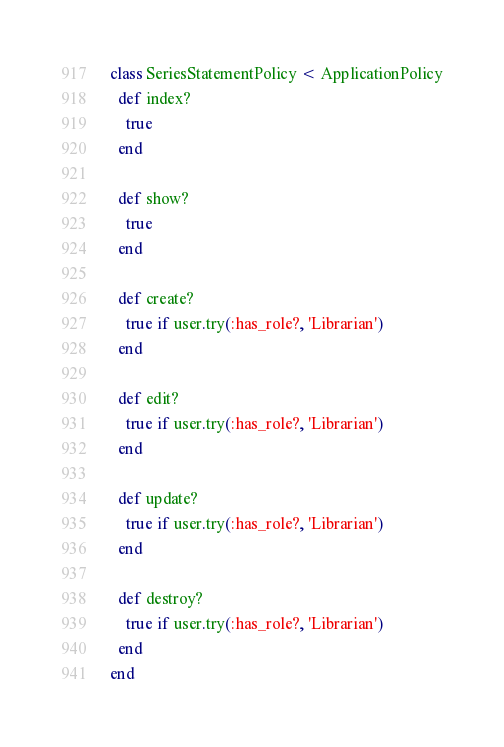Convert code to text. <code><loc_0><loc_0><loc_500><loc_500><_Ruby_>class SeriesStatementPolicy < ApplicationPolicy
  def index?
    true
  end

  def show?
    true
  end

  def create?
    true if user.try(:has_role?, 'Librarian')
  end

  def edit?
    true if user.try(:has_role?, 'Librarian')
  end

  def update?
    true if user.try(:has_role?, 'Librarian')
  end

  def destroy?
    true if user.try(:has_role?, 'Librarian')
  end
end
</code> 